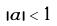Convert formula to latex. <formula><loc_0><loc_0><loc_500><loc_500>| a | < 1</formula> 